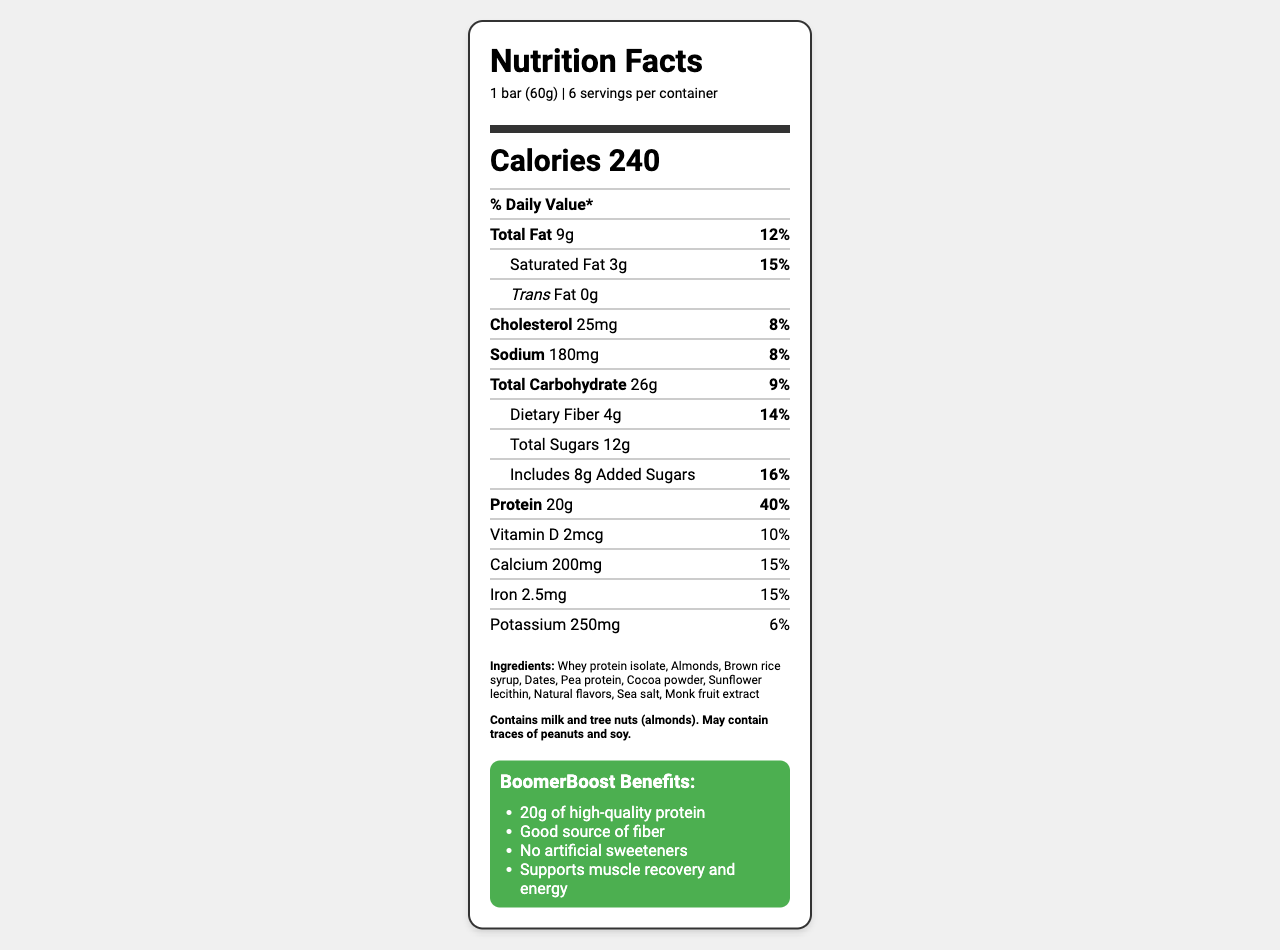what is the product name? The product name is given at the top of the document.
Answer: BoomerBoost High-Protein Energy Bar what is the serving size? The serving size is mentioned in the serving information right below the label header.
Answer: 1 bar (60g) how many calories does one bar contain? The calories per serving are provided in bold in the middle of the document.
Answer: 240 calories what is the amount of protein per serving? The protein content is listed in the "Protein" nutrient row.
Answer: 20g what are the main ingredients in the BoomerBoost bar? The ingredients are listed towards the bottom of the document under the "Ingredients" section.
Answer: Whey protein isolate, Almonds, Brown rice syrup, Dates, Pea protein, Cocoa powder, Sunflower lecithin, Natural flavors, Sea salt, Monk fruit extract how many grams of dietary fiber are in one bar? The dietary fiber amount is listed under the "Total Carbohydrate" section.
Answer: 4g what percentage of the daily value of protein does one bar provide? The daily value percentage for protein is specified next to the protein amount.
Answer: 40% which of the following nutrients has the highest daily value percentage? A. Sodium B. Dietary Fiber C. Added Sugars D. Iron Added sugars have 16%, which is the highest among the options listed.
Answer: C how many servings are there per container? A. 4 B. 6 C. 8 D. 10 The servings per container are indicated as 6 in the serving information section.
Answer: B is the BoomerBoost bar non-GMO and gluten-free? This is mentioned under the certifications section as the product is Non-GMO Project Verified and Gluten-Free Certified.
Answer: Yes describe the main features and benefits of the BoomerBoost High-Protein Energy Bar. The product is specifically formulated for active baby boomers, highlighting high protein content, fiber, and no artificial ingredients, emphasizing benefits like muscle recovery and providing energy. The document also includes packaging, allergen information, distribution channels, and certifications.
Answer: The BoomerBoost High-Protein Energy Bar is designed for active baby boomers aged 55-75. It contains 20g of protein, is a good source of fiber, and has no artificial sweeteners. It supports muscle recovery and energy. The bar is marketed as an ideal fuel for an active lifestyle. It is individually wrapped, includes allergen information, and is distributed through various retail and online channels. how much calcium is in one bar? The calcium amount is listed in the "Calcium" row of the Nutrition Facts section.
Answer: 200mg what is the total carbohydrate amount in one bar? The total carbohydrate amount is mentioned in the "Total Carbohydrate" row.
Answer: 26g what flavors are available for the BoomerBoost bar? The document does not provide information about the available flavors of the BoomerBoost bar.
Answer: Cannot be determined 